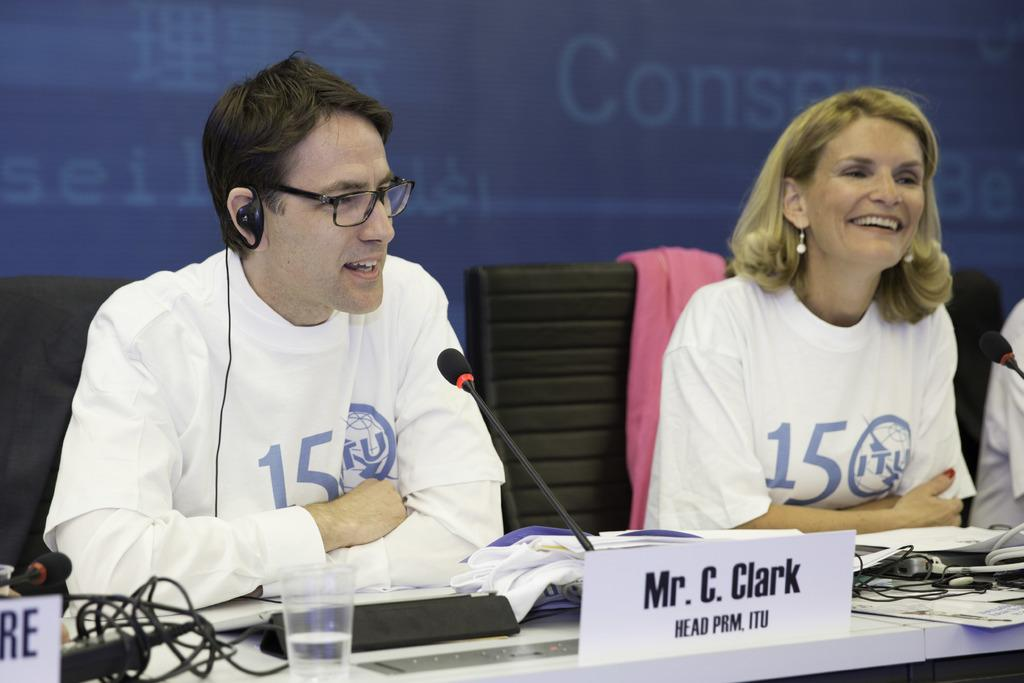What are the people in the image wearing? The man and woman in the image are both wearing white t-shirts. What are the people in the image doing? The man and woman are sitting on chairs in the image. What is on the table in front of them? There is a microphone, books, a water glass, and papers on the table in front of them. What color is the wall behind the people in the image? The wall behind them is blue. Can you see a line of people waiting to use the tongue in the image? There is no line of people or tongue present in the image. 